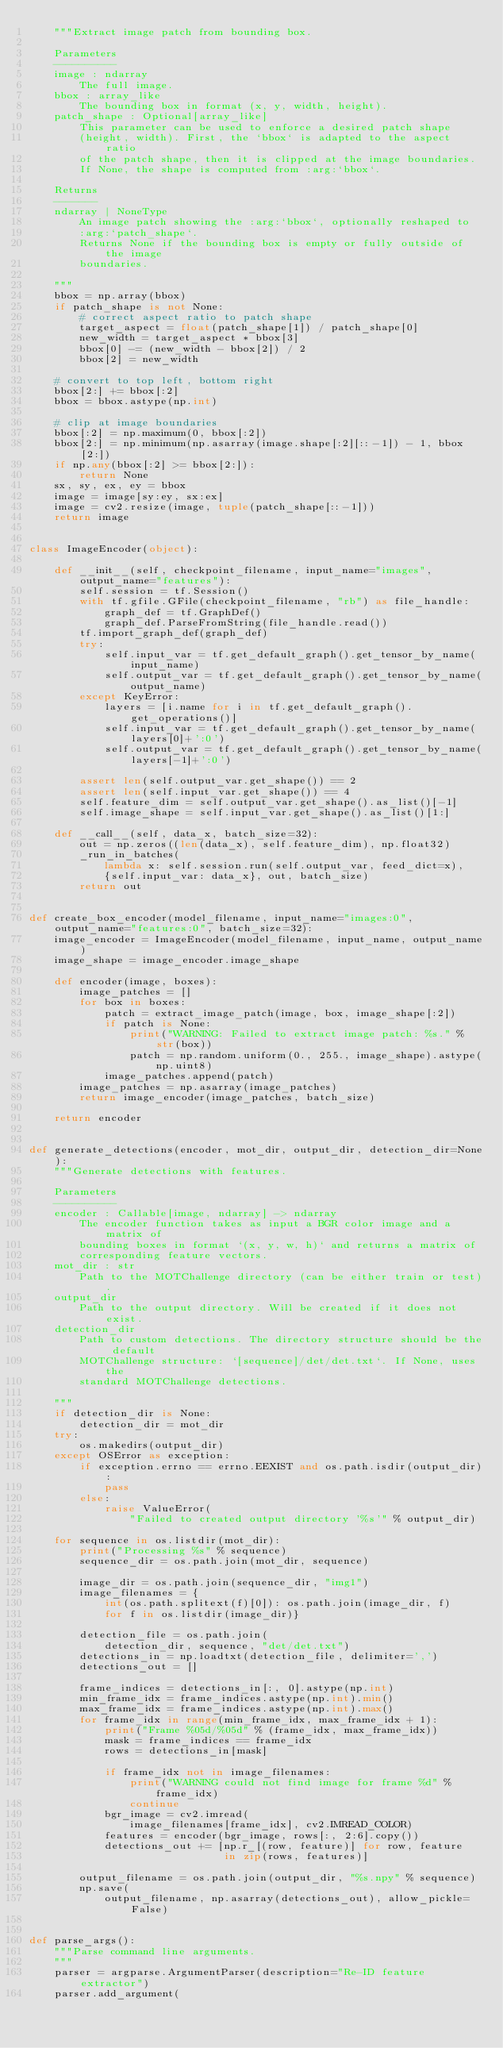Convert code to text. <code><loc_0><loc_0><loc_500><loc_500><_Python_>    """Extract image patch from bounding box.

    Parameters
    ----------
    image : ndarray
        The full image.
    bbox : array_like
        The bounding box in format (x, y, width, height).
    patch_shape : Optional[array_like]
        This parameter can be used to enforce a desired patch shape
        (height, width). First, the `bbox` is adapted to the aspect ratio
        of the patch shape, then it is clipped at the image boundaries.
        If None, the shape is computed from :arg:`bbox`.

    Returns
    -------
    ndarray | NoneType
        An image patch showing the :arg:`bbox`, optionally reshaped to
        :arg:`patch_shape`.
        Returns None if the bounding box is empty or fully outside of the image
        boundaries.

    """
    bbox = np.array(bbox)
    if patch_shape is not None:
        # correct aspect ratio to patch shape
        target_aspect = float(patch_shape[1]) / patch_shape[0]
        new_width = target_aspect * bbox[3]
        bbox[0] -= (new_width - bbox[2]) / 2
        bbox[2] = new_width

    # convert to top left, bottom right
    bbox[2:] += bbox[:2]
    bbox = bbox.astype(np.int)

    # clip at image boundaries
    bbox[:2] = np.maximum(0, bbox[:2])
    bbox[2:] = np.minimum(np.asarray(image.shape[:2][::-1]) - 1, bbox[2:])
    if np.any(bbox[:2] >= bbox[2:]):
        return None
    sx, sy, ex, ey = bbox
    image = image[sy:ey, sx:ex]
    image = cv2.resize(image, tuple(patch_shape[::-1]))
    return image


class ImageEncoder(object):

    def __init__(self, checkpoint_filename, input_name="images", output_name="features"):
        self.session = tf.Session()
        with tf.gfile.GFile(checkpoint_filename, "rb") as file_handle:
            graph_def = tf.GraphDef()
            graph_def.ParseFromString(file_handle.read())
        tf.import_graph_def(graph_def)
        try:
            self.input_var = tf.get_default_graph().get_tensor_by_name(input_name)
            self.output_var = tf.get_default_graph().get_tensor_by_name(output_name)
        except KeyError:
            layers = [i.name for i in tf.get_default_graph().get_operations()]
            self.input_var = tf.get_default_graph().get_tensor_by_name(layers[0]+':0')
            self.output_var = tf.get_default_graph().get_tensor_by_name(layers[-1]+':0')            

        assert len(self.output_var.get_shape()) == 2
        assert len(self.input_var.get_shape()) == 4
        self.feature_dim = self.output_var.get_shape().as_list()[-1]
        self.image_shape = self.input_var.get_shape().as_list()[1:]

    def __call__(self, data_x, batch_size=32):
        out = np.zeros((len(data_x), self.feature_dim), np.float32)
        _run_in_batches(
            lambda x: self.session.run(self.output_var, feed_dict=x),
            {self.input_var: data_x}, out, batch_size)
        return out


def create_box_encoder(model_filename, input_name="images:0", output_name="features:0", batch_size=32):
    image_encoder = ImageEncoder(model_filename, input_name, output_name)
    image_shape = image_encoder.image_shape

    def encoder(image, boxes):
        image_patches = []
        for box in boxes:
            patch = extract_image_patch(image, box, image_shape[:2])
            if patch is None:
                print("WARNING: Failed to extract image patch: %s." % str(box))
                patch = np.random.uniform(0., 255., image_shape).astype(np.uint8)
            image_patches.append(patch)
        image_patches = np.asarray(image_patches)
        return image_encoder(image_patches, batch_size)

    return encoder


def generate_detections(encoder, mot_dir, output_dir, detection_dir=None):
    """Generate detections with features.

    Parameters
    ----------
    encoder : Callable[image, ndarray] -> ndarray
        The encoder function takes as input a BGR color image and a matrix of
        bounding boxes in format `(x, y, w, h)` and returns a matrix of
        corresponding feature vectors.
    mot_dir : str
        Path to the MOTChallenge directory (can be either train or test).
    output_dir
        Path to the output directory. Will be created if it does not exist.
    detection_dir
        Path to custom detections. The directory structure should be the default
        MOTChallenge structure: `[sequence]/det/det.txt`. If None, uses the
        standard MOTChallenge detections.

    """
    if detection_dir is None:
        detection_dir = mot_dir
    try:
        os.makedirs(output_dir)
    except OSError as exception:
        if exception.errno == errno.EEXIST and os.path.isdir(output_dir):
            pass
        else:
            raise ValueError(
                "Failed to created output directory '%s'" % output_dir)

    for sequence in os.listdir(mot_dir):
        print("Processing %s" % sequence)
        sequence_dir = os.path.join(mot_dir, sequence)

        image_dir = os.path.join(sequence_dir, "img1")
        image_filenames = {
            int(os.path.splitext(f)[0]): os.path.join(image_dir, f)
            for f in os.listdir(image_dir)}

        detection_file = os.path.join(
            detection_dir, sequence, "det/det.txt")
        detections_in = np.loadtxt(detection_file, delimiter=',')
        detections_out = []

        frame_indices = detections_in[:, 0].astype(np.int)
        min_frame_idx = frame_indices.astype(np.int).min()
        max_frame_idx = frame_indices.astype(np.int).max()
        for frame_idx in range(min_frame_idx, max_frame_idx + 1):
            print("Frame %05d/%05d" % (frame_idx, max_frame_idx))
            mask = frame_indices == frame_idx
            rows = detections_in[mask]

            if frame_idx not in image_filenames:
                print("WARNING could not find image for frame %d" % frame_idx)
                continue
            bgr_image = cv2.imread(
                image_filenames[frame_idx], cv2.IMREAD_COLOR)
            features = encoder(bgr_image, rows[:, 2:6].copy())
            detections_out += [np.r_[(row, feature)] for row, feature
                               in zip(rows, features)]

        output_filename = os.path.join(output_dir, "%s.npy" % sequence)
        np.save(
            output_filename, np.asarray(detections_out), allow_pickle=False)


def parse_args():
    """Parse command line arguments.
    """
    parser = argparse.ArgumentParser(description="Re-ID feature extractor")
    parser.add_argument(</code> 